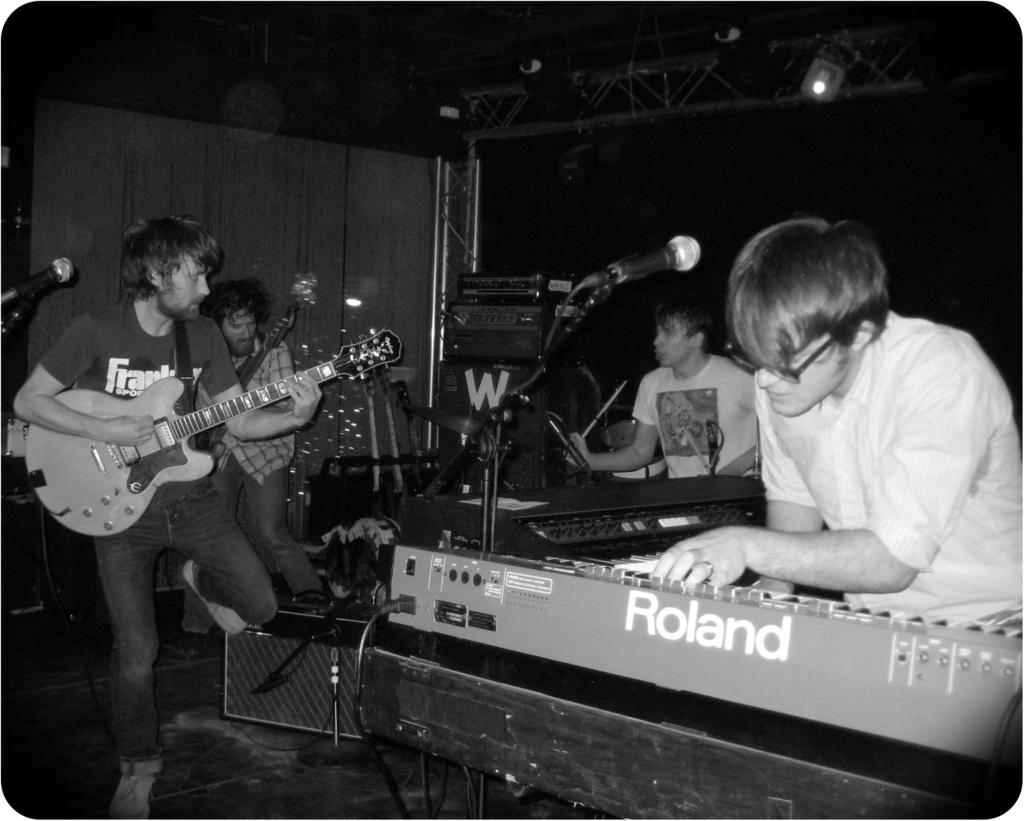<image>
Relay a brief, clear account of the picture shown. A band playing on a stage with one of the members playing a Roland keyboard. 